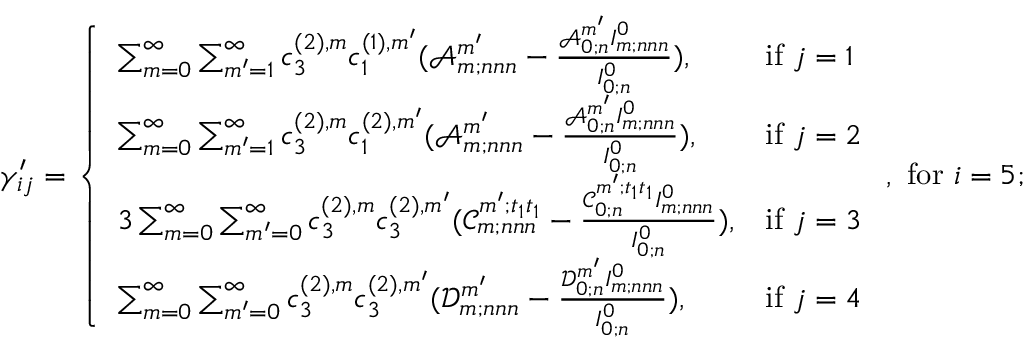<formula> <loc_0><loc_0><loc_500><loc_500>\gamma _ { i j } ^ { \prime } = \left \{ \begin{array} { l l } { \sum _ { m = 0 } ^ { \infty } \sum _ { m ^ { \prime } = 1 } ^ { \infty } c _ { 3 } ^ { ( 2 ) , m } c _ { 1 } ^ { ( 1 ) , m ^ { \prime } } ( \ m a t h s c r { A } _ { m ; n n n } ^ { m ^ { \prime } } - \frac { \ m a t h s c r { A } _ { 0 ; n } ^ { m ^ { \prime } } I _ { m ; n n n } ^ { 0 } } { I _ { 0 ; n } ^ { 0 } } ) , } & { i f j = 1 } \\ { \sum _ { m = 0 } ^ { \infty } \sum _ { m ^ { \prime } = 1 } ^ { \infty } c _ { 3 } ^ { ( 2 ) , m } c _ { 1 } ^ { ( 2 ) , m ^ { \prime } } ( \ m a t h s c r { A } _ { m ; n n n } ^ { m ^ { \prime } } - \frac { \ m a t h s c r { A } _ { 0 ; n } ^ { m ^ { \prime } } I _ { m ; n n n } ^ { 0 } } { I _ { 0 ; n } ^ { 0 } } ) , } & { i f j = 2 } \\ { 3 \sum _ { m = 0 } ^ { \infty } \sum _ { m ^ { \prime } = 0 } ^ { \infty } c _ { 3 } ^ { ( 2 ) , m } c _ { 3 } ^ { ( 2 ) , m ^ { \prime } } ( \ m a t h s c r { C } _ { m ; n n n } ^ { m ^ { \prime } ; t _ { 1 } t _ { 1 } } - \frac { \ m a t h s c r { C } _ { 0 ; n } ^ { m ^ { \prime } ; t _ { 1 } t _ { 1 } } I _ { m ; n n n } ^ { 0 } } { I _ { 0 ; n } ^ { 0 } } ) , } & { i f j = 3 } \\ { \sum _ { m = 0 } ^ { \infty } \sum _ { m ^ { \prime } = 0 } ^ { \infty } c _ { 3 } ^ { ( 2 ) , m } c _ { 3 } ^ { ( 2 ) , m ^ { \prime } } ( \ m a t h s c r { D } _ { m ; n n n } ^ { m ^ { \prime } } - \frac { \ m a t h s c r { D } _ { 0 ; n } ^ { m ^ { \prime } } I _ { m ; n n n } ^ { 0 } } { I _ { 0 ; n } ^ { 0 } } ) , } & { i f j = 4 } \end{array} , f o r i = 5 ;</formula> 